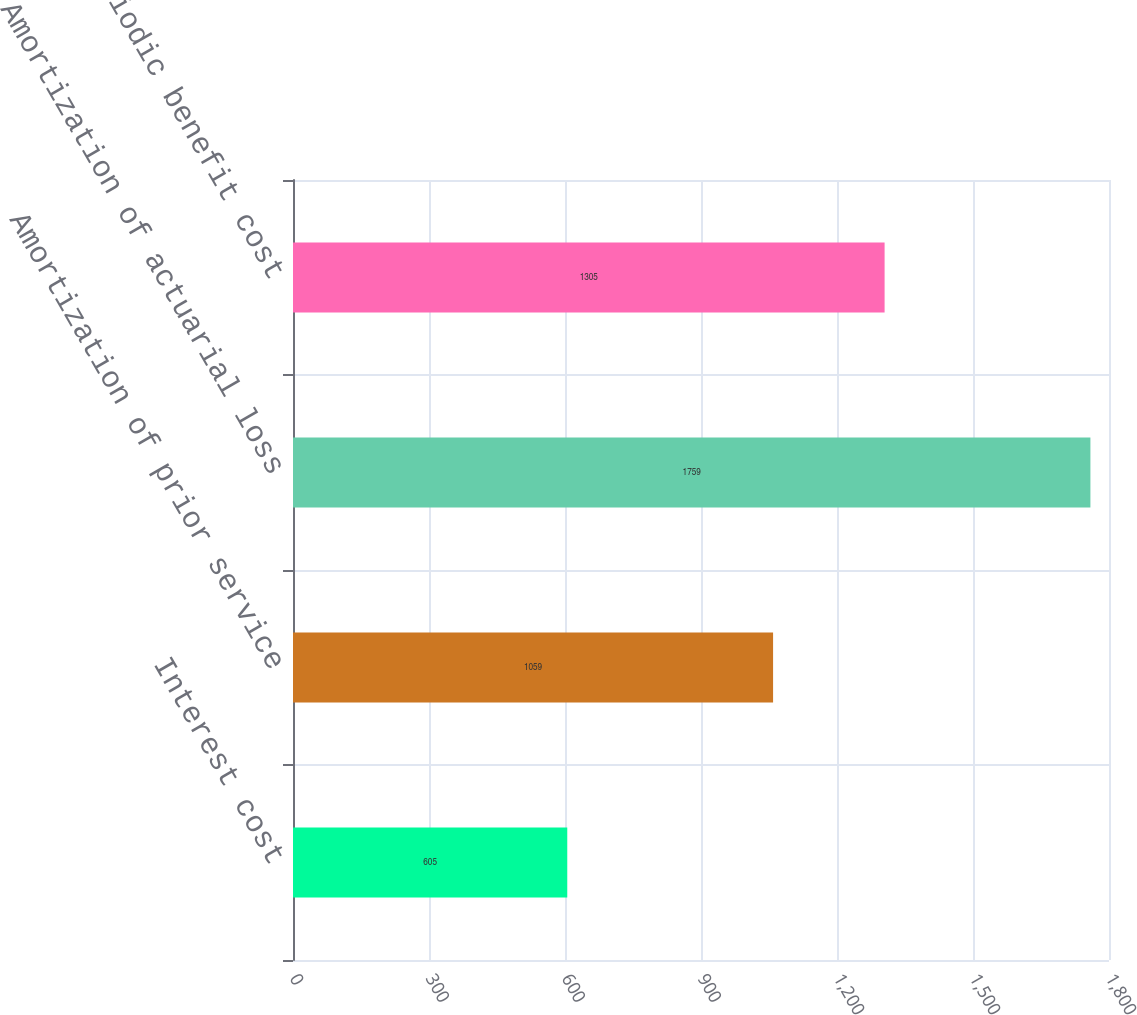Convert chart. <chart><loc_0><loc_0><loc_500><loc_500><bar_chart><fcel>Interest cost<fcel>Amortization of prior service<fcel>Amortization of actuarial loss<fcel>Net periodic benefit cost<nl><fcel>605<fcel>1059<fcel>1759<fcel>1305<nl></chart> 